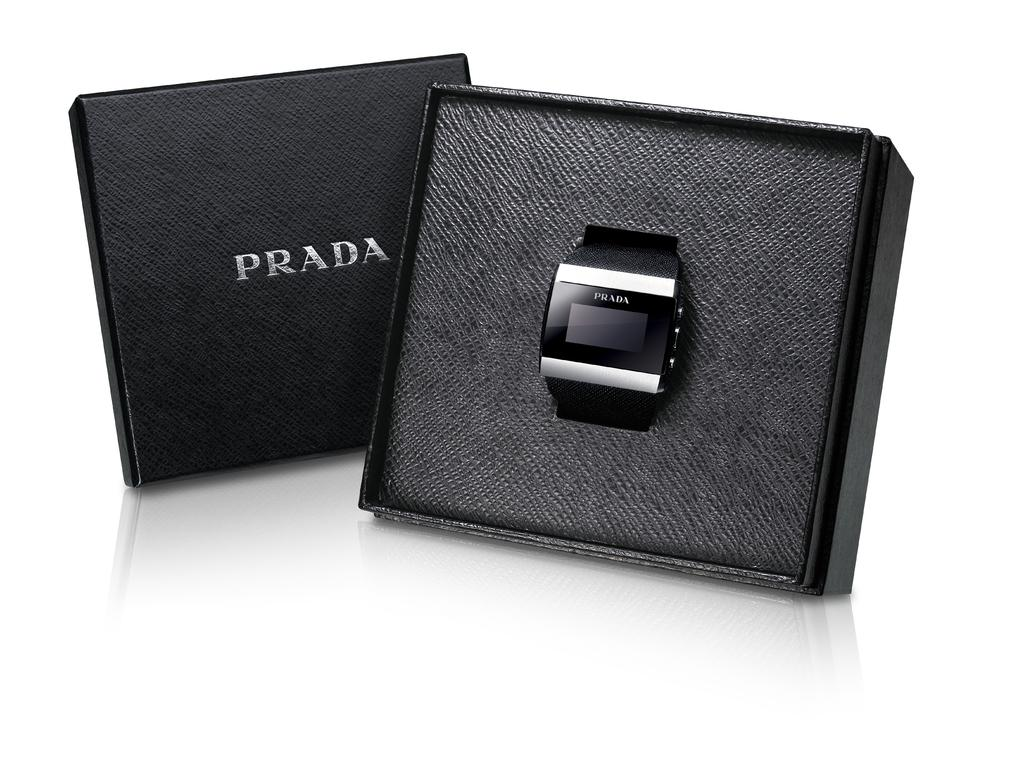Provide a one-sentence caption for the provided image. An electronic watch with Prada written on it sits in a black box that has a cover that also says Prada. 